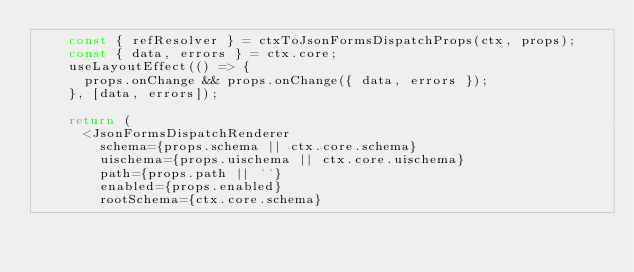Convert code to text. <code><loc_0><loc_0><loc_500><loc_500><_TypeScript_>    const { refResolver } = ctxToJsonFormsDispatchProps(ctx, props);
    const { data, errors } = ctx.core;
    useLayoutEffect(() => {
      props.onChange && props.onChange({ data, errors });
    }, [data, errors]);

    return (
      <JsonFormsDispatchRenderer
        schema={props.schema || ctx.core.schema}
        uischema={props.uischema || ctx.core.uischema}
        path={props.path || ''}
        enabled={props.enabled}
        rootSchema={ctx.core.schema}</code> 